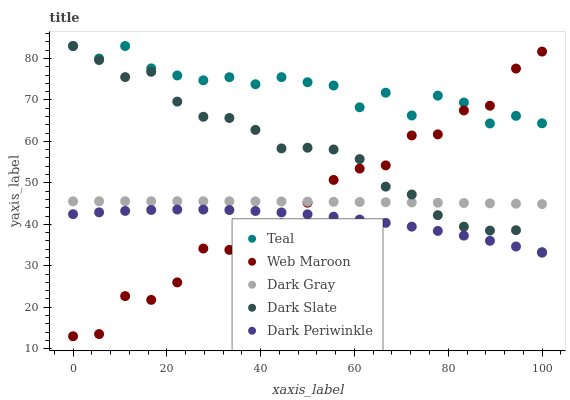Does Dark Periwinkle have the minimum area under the curve?
Answer yes or no. Yes. Does Teal have the maximum area under the curve?
Answer yes or no. Yes. Does Dark Slate have the minimum area under the curve?
Answer yes or no. No. Does Dark Slate have the maximum area under the curve?
Answer yes or no. No. Is Dark Gray the smoothest?
Answer yes or no. Yes. Is Web Maroon the roughest?
Answer yes or no. Yes. Is Dark Slate the smoothest?
Answer yes or no. No. Is Dark Slate the roughest?
Answer yes or no. No. Does Web Maroon have the lowest value?
Answer yes or no. Yes. Does Dark Slate have the lowest value?
Answer yes or no. No. Does Teal have the highest value?
Answer yes or no. Yes. Does Web Maroon have the highest value?
Answer yes or no. No. Is Dark Periwinkle less than Dark Slate?
Answer yes or no. Yes. Is Teal greater than Dark Gray?
Answer yes or no. Yes. Does Web Maroon intersect Teal?
Answer yes or no. Yes. Is Web Maroon less than Teal?
Answer yes or no. No. Is Web Maroon greater than Teal?
Answer yes or no. No. Does Dark Periwinkle intersect Dark Slate?
Answer yes or no. No. 